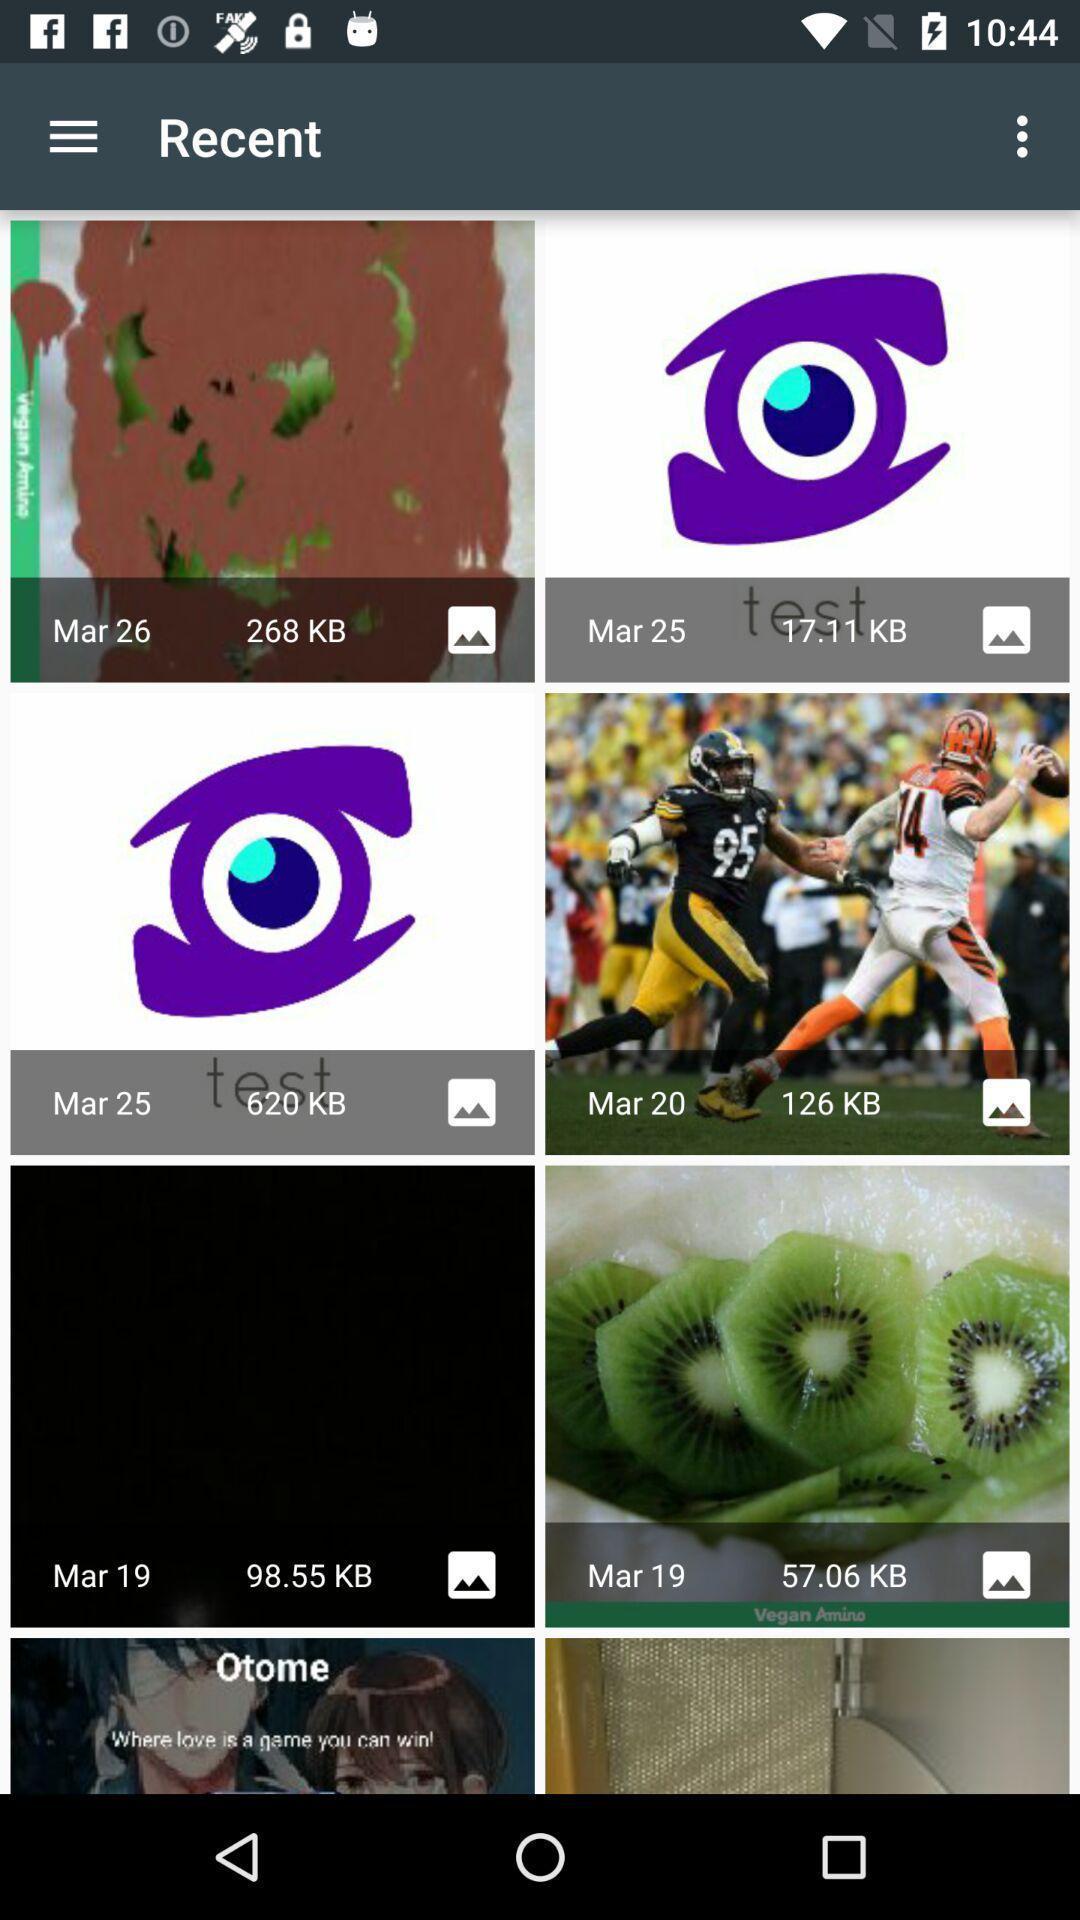Give me a summary of this screen capture. Page displaying various images. 